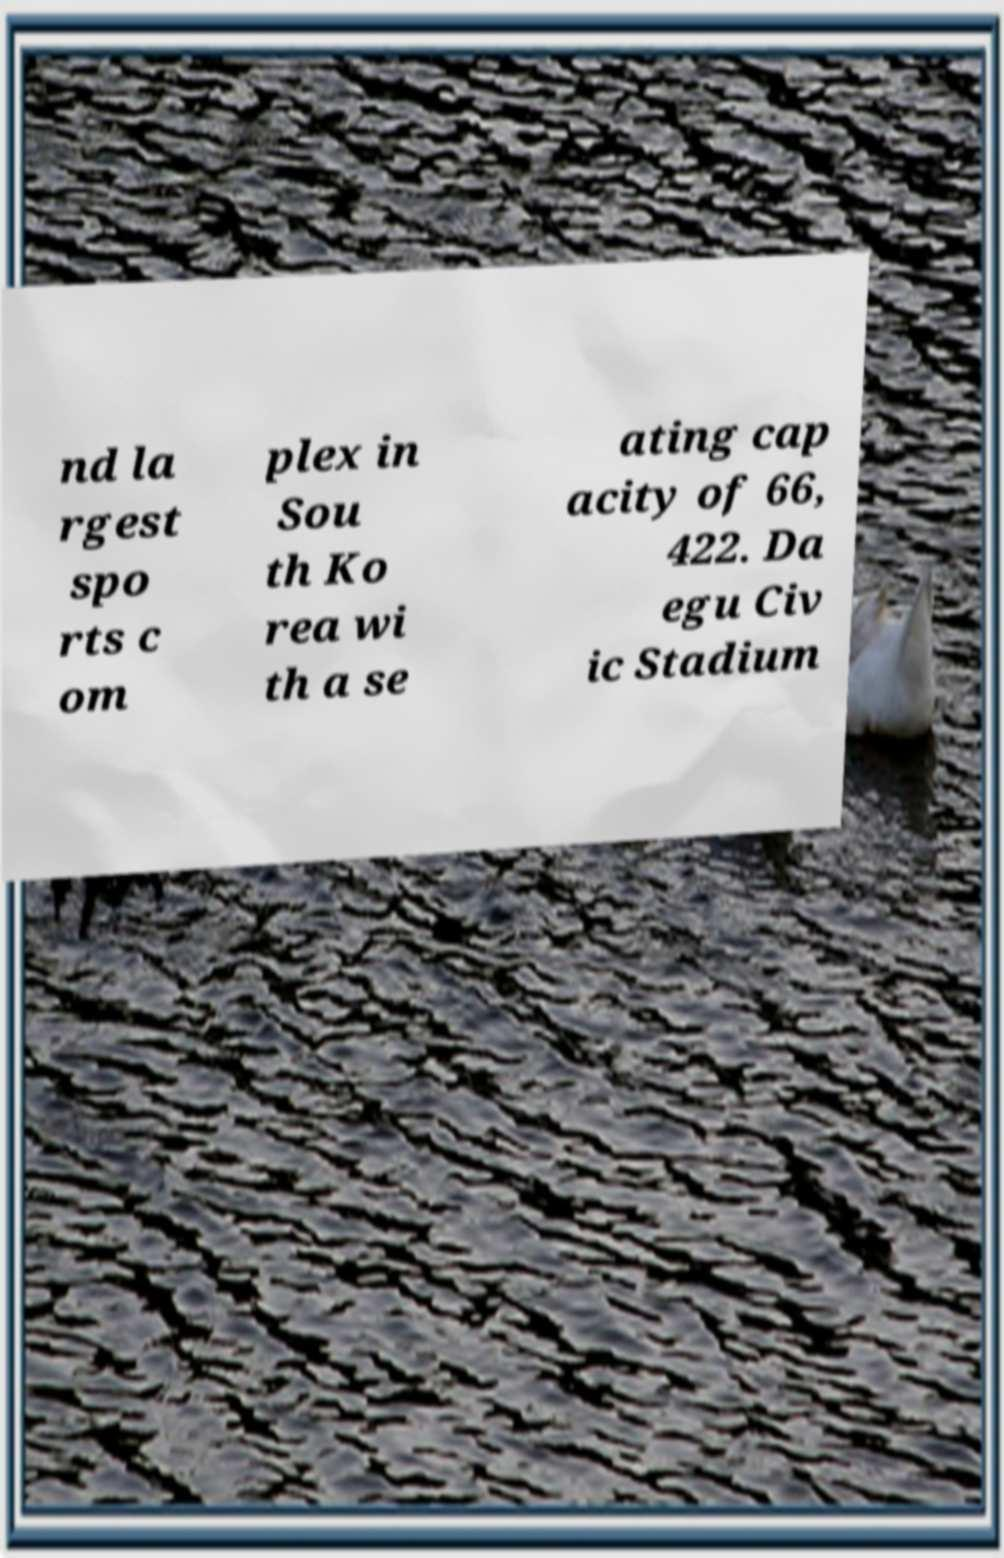What messages or text are displayed in this image? I need them in a readable, typed format. nd la rgest spo rts c om plex in Sou th Ko rea wi th a se ating cap acity of 66, 422. Da egu Civ ic Stadium 